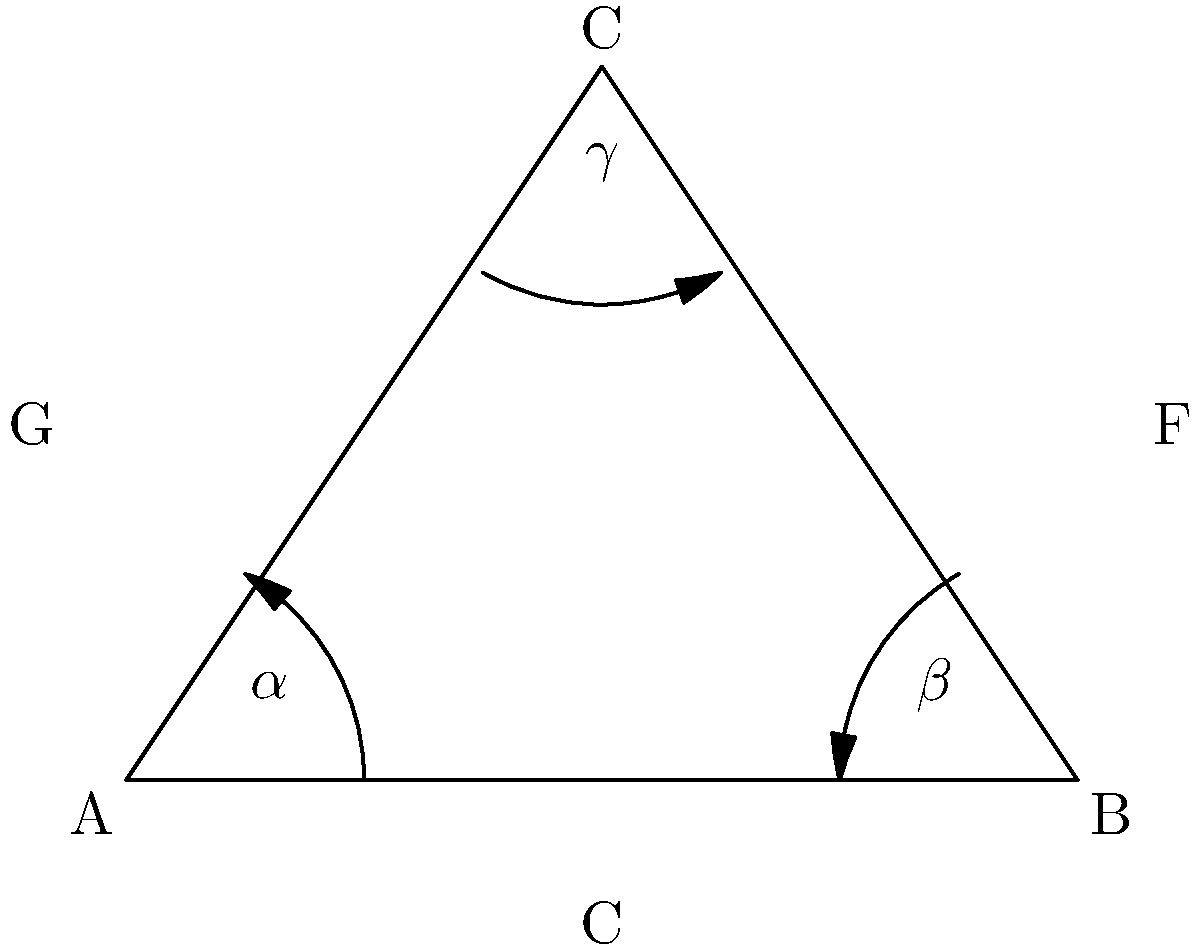In a hyperbolic plane representing musical notes, a triangle ABC is formed where each vertex corresponds to a distinct note. The angles $\alpha$, $\beta$, and $\gamma$ at vertices A, B, and C respectively represent the harmonic relationships between the notes. If the sum of these angles is $150°$, what is the area of the triangle in terms of $\pi$ radians squared? To solve this problem, we need to use the properties of hyperbolic geometry and its relation to musical harmony. Let's approach this step-by-step:

1) In Euclidean geometry, the sum of angles in a triangle is always $180°$ or $\pi$ radians. However, in hyperbolic geometry, this sum is always less than $180°$.

2) The difference between $180°$ and the sum of the angles in a hyperbolic triangle is directly related to the area of the triangle. This relationship is given by the Gauss-Bonnet theorem.

3) The Gauss-Bonnet theorem for hyperbolic triangles states that:

   Area = $\pi - (\alpha + \beta + \gamma)$

   where the angles are measured in radians.

4) We are given that $\alpha + \beta + \gamma = 150°$. We need to convert this to radians:

   $150° \times \frac{\pi}{180°} = \frac{5\pi}{6}$ radians

5) Now we can substitute this into our formula:

   Area = $\pi - \frac{5\pi}{6} = \frac{\pi}{6}$

6) Therefore, the area of the triangle is $\frac{\pi}{6}$ square radians.

In the context of music theory, this hyperbolic representation could be interpreted as a way to visualize harmonic relationships between notes, where the area of the triangle represents the complexity or richness of the harmonic interaction.
Answer: $\frac{\pi}{6}$ square radians 